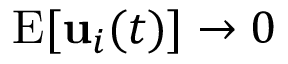Convert formula to latex. <formula><loc_0><loc_0><loc_500><loc_500>E [ { u } _ { i } ( t ) ] \rightarrow 0</formula> 